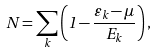Convert formula to latex. <formula><loc_0><loc_0><loc_500><loc_500>N = \sum _ { k } \left ( 1 - \frac { \varepsilon _ { k } - \mu } { E _ { k } } \right ) ,</formula> 